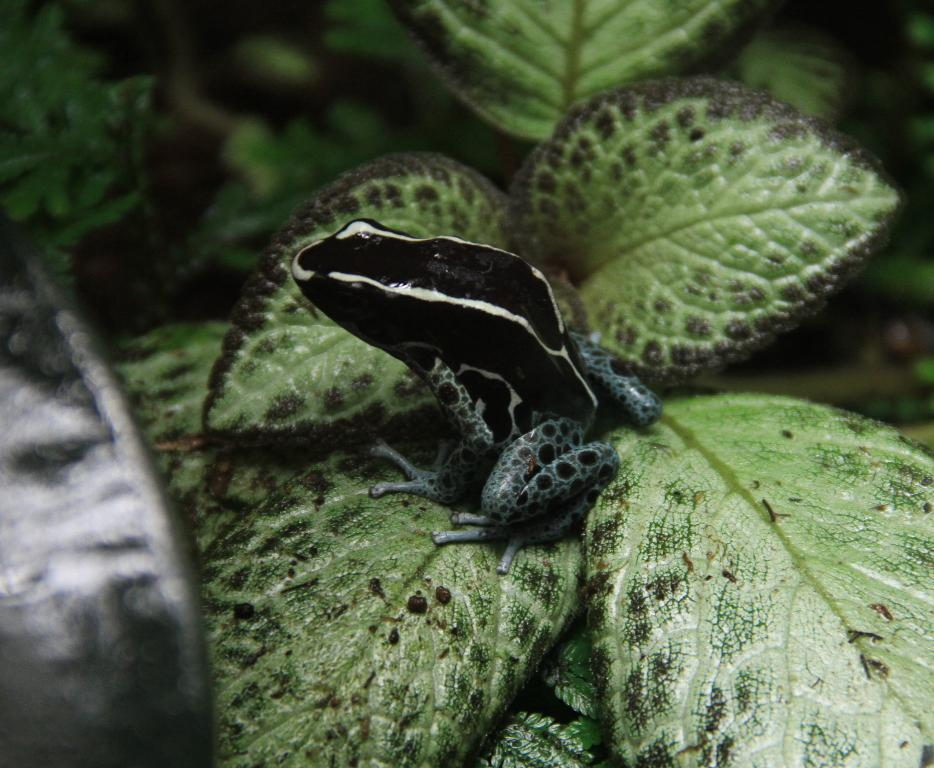What type of animal is in the image? There is a black frog in the image. Where is the frog located? The frog is sitting on a plant. What type of love is the frog expressing in the image? There is no indication of love or any emotion in the image; it simply shows a black frog sitting on a plant. 